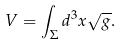Convert formula to latex. <formula><loc_0><loc_0><loc_500><loc_500>V = \int _ { \Sigma } d ^ { 3 } x \sqrt { g } .</formula> 